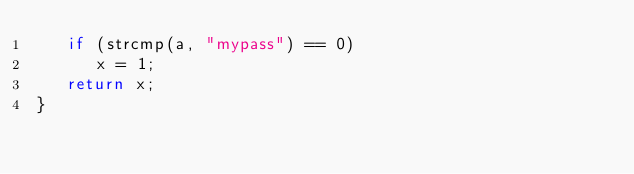<code> <loc_0><loc_0><loc_500><loc_500><_C_>   if (strcmp(a, "mypass") == 0)
      x = 1;
   return x;
}
</code> 